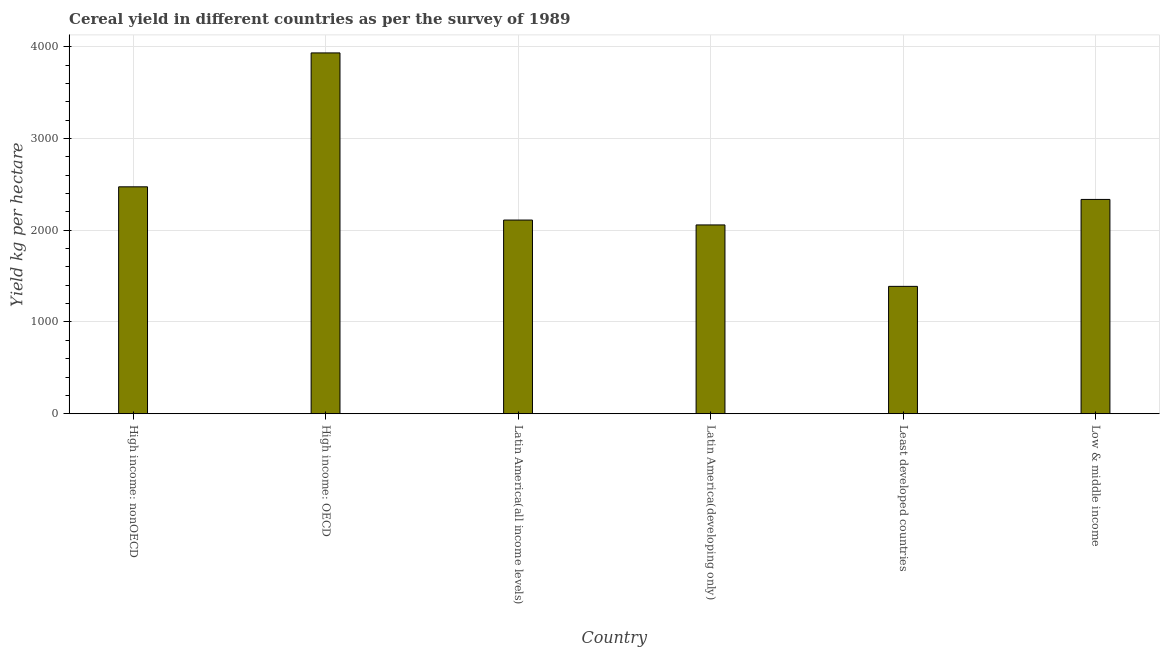Does the graph contain any zero values?
Give a very brief answer. No. What is the title of the graph?
Your answer should be compact. Cereal yield in different countries as per the survey of 1989. What is the label or title of the Y-axis?
Offer a terse response. Yield kg per hectare. What is the cereal yield in High income: OECD?
Provide a short and direct response. 3933.01. Across all countries, what is the maximum cereal yield?
Provide a succinct answer. 3933.01. Across all countries, what is the minimum cereal yield?
Provide a short and direct response. 1388.34. In which country was the cereal yield maximum?
Offer a very short reply. High income: OECD. In which country was the cereal yield minimum?
Offer a very short reply. Least developed countries. What is the sum of the cereal yield?
Provide a short and direct response. 1.43e+04. What is the difference between the cereal yield in Latin America(all income levels) and Latin America(developing only)?
Your response must be concise. 53.21. What is the average cereal yield per country?
Make the answer very short. 2383.32. What is the median cereal yield?
Your response must be concise. 2223.59. In how many countries, is the cereal yield greater than 600 kg per hectare?
Provide a succinct answer. 6. What is the ratio of the cereal yield in Latin America(all income levels) to that in Least developed countries?
Keep it short and to the point. 1.52. What is the difference between the highest and the second highest cereal yield?
Your answer should be very brief. 1459.63. What is the difference between the highest and the lowest cereal yield?
Give a very brief answer. 2544.67. How many bars are there?
Keep it short and to the point. 6. Are all the bars in the graph horizontal?
Offer a very short reply. No. How many countries are there in the graph?
Provide a short and direct response. 6. What is the difference between two consecutive major ticks on the Y-axis?
Give a very brief answer. 1000. Are the values on the major ticks of Y-axis written in scientific E-notation?
Ensure brevity in your answer.  No. What is the Yield kg per hectare of High income: nonOECD?
Offer a terse response. 2473.37. What is the Yield kg per hectare of High income: OECD?
Ensure brevity in your answer.  3933.01. What is the Yield kg per hectare in Latin America(all income levels)?
Offer a very short reply. 2111.21. What is the Yield kg per hectare of Latin America(developing only)?
Keep it short and to the point. 2058.01. What is the Yield kg per hectare in Least developed countries?
Your response must be concise. 1388.34. What is the Yield kg per hectare in Low & middle income?
Make the answer very short. 2335.96. What is the difference between the Yield kg per hectare in High income: nonOECD and High income: OECD?
Your answer should be compact. -1459.63. What is the difference between the Yield kg per hectare in High income: nonOECD and Latin America(all income levels)?
Your response must be concise. 362.16. What is the difference between the Yield kg per hectare in High income: nonOECD and Latin America(developing only)?
Provide a succinct answer. 415.36. What is the difference between the Yield kg per hectare in High income: nonOECD and Least developed countries?
Your answer should be very brief. 1085.03. What is the difference between the Yield kg per hectare in High income: nonOECD and Low & middle income?
Ensure brevity in your answer.  137.41. What is the difference between the Yield kg per hectare in High income: OECD and Latin America(all income levels)?
Provide a short and direct response. 1821.79. What is the difference between the Yield kg per hectare in High income: OECD and Latin America(developing only)?
Your response must be concise. 1875. What is the difference between the Yield kg per hectare in High income: OECD and Least developed countries?
Give a very brief answer. 2544.67. What is the difference between the Yield kg per hectare in High income: OECD and Low & middle income?
Offer a very short reply. 1597.05. What is the difference between the Yield kg per hectare in Latin America(all income levels) and Latin America(developing only)?
Ensure brevity in your answer.  53.21. What is the difference between the Yield kg per hectare in Latin America(all income levels) and Least developed countries?
Your answer should be compact. 722.88. What is the difference between the Yield kg per hectare in Latin America(all income levels) and Low & middle income?
Make the answer very short. -224.75. What is the difference between the Yield kg per hectare in Latin America(developing only) and Least developed countries?
Your answer should be compact. 669.67. What is the difference between the Yield kg per hectare in Latin America(developing only) and Low & middle income?
Offer a very short reply. -277.95. What is the difference between the Yield kg per hectare in Least developed countries and Low & middle income?
Keep it short and to the point. -947.62. What is the ratio of the Yield kg per hectare in High income: nonOECD to that in High income: OECD?
Provide a short and direct response. 0.63. What is the ratio of the Yield kg per hectare in High income: nonOECD to that in Latin America(all income levels)?
Your answer should be very brief. 1.17. What is the ratio of the Yield kg per hectare in High income: nonOECD to that in Latin America(developing only)?
Provide a succinct answer. 1.2. What is the ratio of the Yield kg per hectare in High income: nonOECD to that in Least developed countries?
Offer a terse response. 1.78. What is the ratio of the Yield kg per hectare in High income: nonOECD to that in Low & middle income?
Keep it short and to the point. 1.06. What is the ratio of the Yield kg per hectare in High income: OECD to that in Latin America(all income levels)?
Provide a succinct answer. 1.86. What is the ratio of the Yield kg per hectare in High income: OECD to that in Latin America(developing only)?
Make the answer very short. 1.91. What is the ratio of the Yield kg per hectare in High income: OECD to that in Least developed countries?
Keep it short and to the point. 2.83. What is the ratio of the Yield kg per hectare in High income: OECD to that in Low & middle income?
Your answer should be very brief. 1.68. What is the ratio of the Yield kg per hectare in Latin America(all income levels) to that in Latin America(developing only)?
Make the answer very short. 1.03. What is the ratio of the Yield kg per hectare in Latin America(all income levels) to that in Least developed countries?
Ensure brevity in your answer.  1.52. What is the ratio of the Yield kg per hectare in Latin America(all income levels) to that in Low & middle income?
Your answer should be compact. 0.9. What is the ratio of the Yield kg per hectare in Latin America(developing only) to that in Least developed countries?
Your answer should be very brief. 1.48. What is the ratio of the Yield kg per hectare in Latin America(developing only) to that in Low & middle income?
Keep it short and to the point. 0.88. What is the ratio of the Yield kg per hectare in Least developed countries to that in Low & middle income?
Provide a short and direct response. 0.59. 